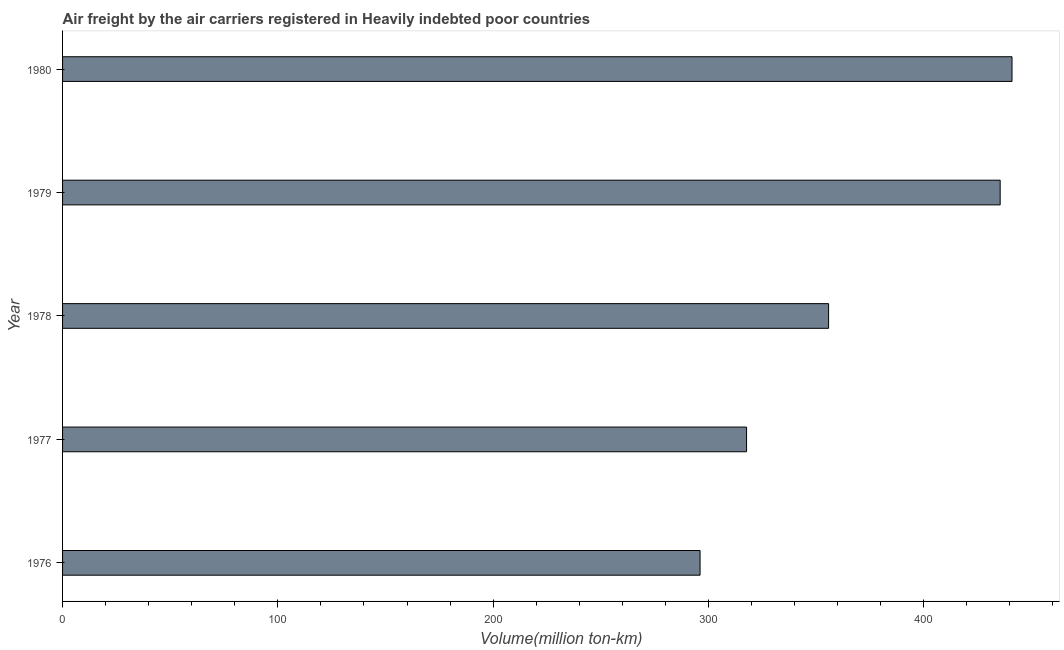What is the title of the graph?
Make the answer very short. Air freight by the air carriers registered in Heavily indebted poor countries. What is the label or title of the X-axis?
Make the answer very short. Volume(million ton-km). What is the air freight in 1980?
Offer a terse response. 441. Across all years, what is the maximum air freight?
Your answer should be very brief. 441. Across all years, what is the minimum air freight?
Offer a terse response. 296.1. In which year was the air freight maximum?
Give a very brief answer. 1980. In which year was the air freight minimum?
Offer a terse response. 1976. What is the sum of the air freight?
Your answer should be compact. 1846.1. What is the difference between the air freight in 1976 and 1979?
Offer a very short reply. -139.4. What is the average air freight per year?
Offer a very short reply. 369.22. What is the median air freight?
Give a very brief answer. 355.8. What is the ratio of the air freight in 1977 to that in 1978?
Provide a short and direct response. 0.89. What is the difference between the highest and the lowest air freight?
Your answer should be compact. 144.9. How many years are there in the graph?
Provide a succinct answer. 5. What is the difference between two consecutive major ticks on the X-axis?
Your answer should be very brief. 100. Are the values on the major ticks of X-axis written in scientific E-notation?
Your answer should be compact. No. What is the Volume(million ton-km) of 1976?
Your answer should be compact. 296.1. What is the Volume(million ton-km) of 1977?
Your answer should be compact. 317.7. What is the Volume(million ton-km) of 1978?
Your response must be concise. 355.8. What is the Volume(million ton-km) of 1979?
Your answer should be very brief. 435.5. What is the Volume(million ton-km) of 1980?
Provide a succinct answer. 441. What is the difference between the Volume(million ton-km) in 1976 and 1977?
Offer a terse response. -21.6. What is the difference between the Volume(million ton-km) in 1976 and 1978?
Offer a terse response. -59.7. What is the difference between the Volume(million ton-km) in 1976 and 1979?
Offer a very short reply. -139.4. What is the difference between the Volume(million ton-km) in 1976 and 1980?
Offer a terse response. -144.9. What is the difference between the Volume(million ton-km) in 1977 and 1978?
Your answer should be very brief. -38.1. What is the difference between the Volume(million ton-km) in 1977 and 1979?
Your response must be concise. -117.8. What is the difference between the Volume(million ton-km) in 1977 and 1980?
Your response must be concise. -123.3. What is the difference between the Volume(million ton-km) in 1978 and 1979?
Offer a very short reply. -79.7. What is the difference between the Volume(million ton-km) in 1978 and 1980?
Provide a short and direct response. -85.2. What is the difference between the Volume(million ton-km) in 1979 and 1980?
Give a very brief answer. -5.5. What is the ratio of the Volume(million ton-km) in 1976 to that in 1977?
Offer a terse response. 0.93. What is the ratio of the Volume(million ton-km) in 1976 to that in 1978?
Your answer should be very brief. 0.83. What is the ratio of the Volume(million ton-km) in 1976 to that in 1979?
Give a very brief answer. 0.68. What is the ratio of the Volume(million ton-km) in 1976 to that in 1980?
Your response must be concise. 0.67. What is the ratio of the Volume(million ton-km) in 1977 to that in 1978?
Ensure brevity in your answer.  0.89. What is the ratio of the Volume(million ton-km) in 1977 to that in 1979?
Ensure brevity in your answer.  0.73. What is the ratio of the Volume(million ton-km) in 1977 to that in 1980?
Offer a very short reply. 0.72. What is the ratio of the Volume(million ton-km) in 1978 to that in 1979?
Make the answer very short. 0.82. What is the ratio of the Volume(million ton-km) in 1978 to that in 1980?
Ensure brevity in your answer.  0.81. 